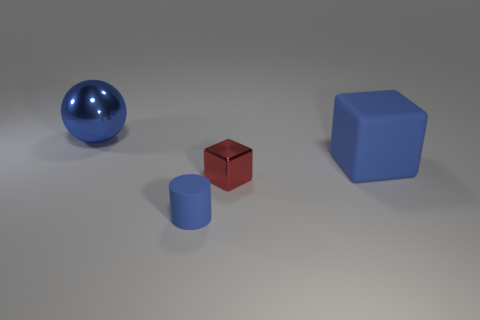Add 2 matte cylinders. How many objects exist? 6 Subtract 1 blocks. How many blocks are left? 1 Subtract all gray blocks. Subtract all yellow cylinders. How many blocks are left? 2 Subtract all yellow balls. How many cyan cylinders are left? 0 Subtract all tiny blue objects. Subtract all purple metal balls. How many objects are left? 3 Add 1 matte things. How many matte things are left? 3 Add 4 cyan rubber cylinders. How many cyan rubber cylinders exist? 4 Subtract all blue cubes. How many cubes are left? 1 Subtract 0 green spheres. How many objects are left? 4 